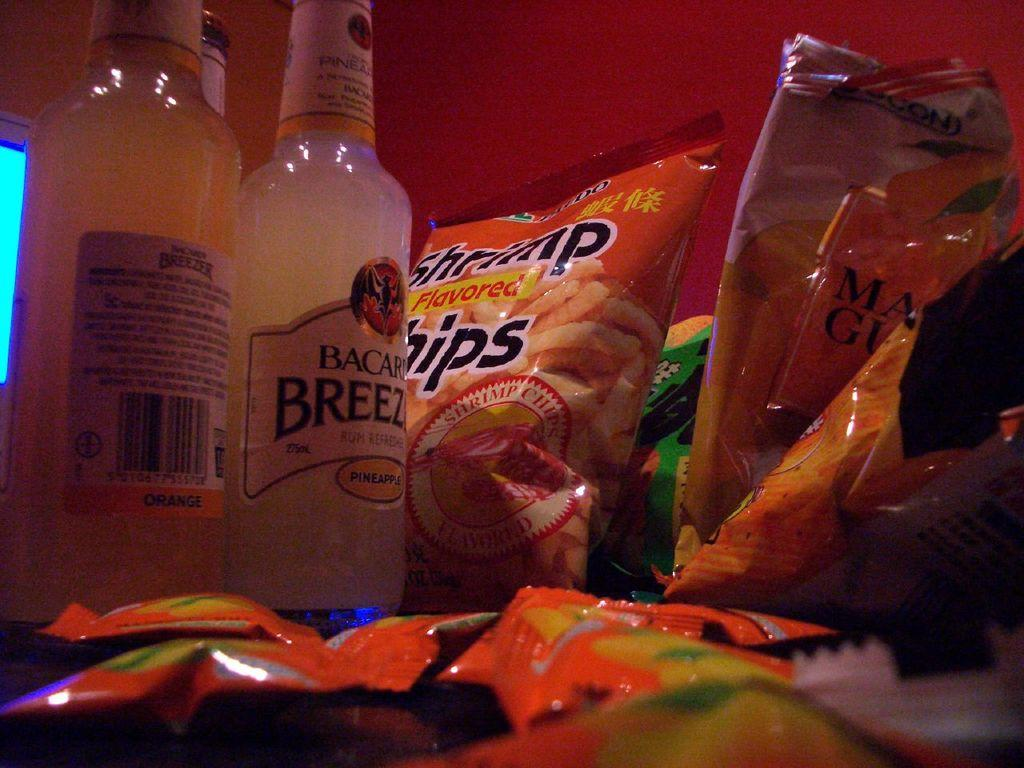<image>
Relay a brief, clear account of the picture shown. Bags of Shrimp chips next to bottles of Bacardi. 